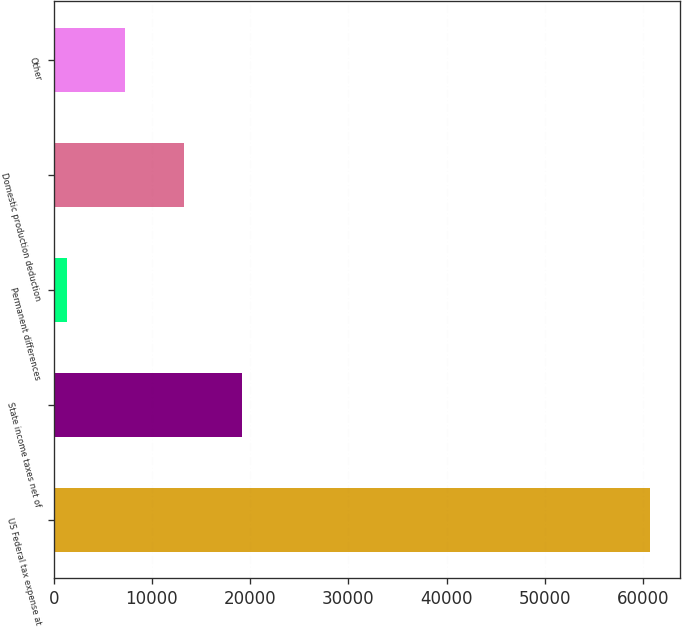Convert chart to OTSL. <chart><loc_0><loc_0><loc_500><loc_500><bar_chart><fcel>US Federal tax expense at<fcel>State income taxes net of<fcel>Permanent differences<fcel>Domestic production deduction<fcel>Other<nl><fcel>60717<fcel>19155.9<fcel>1344<fcel>13218.6<fcel>7281.3<nl></chart> 